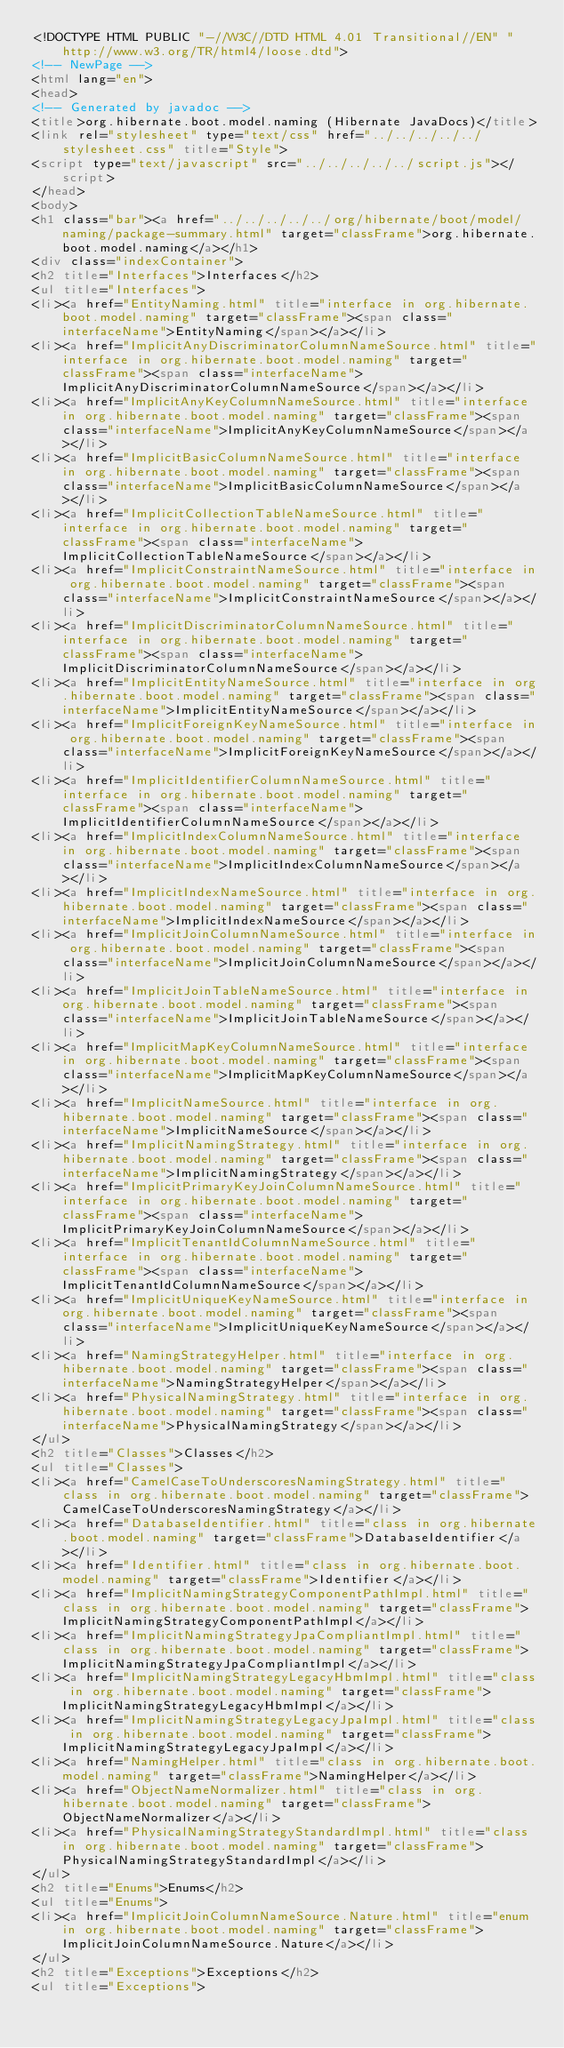Convert code to text. <code><loc_0><loc_0><loc_500><loc_500><_HTML_><!DOCTYPE HTML PUBLIC "-//W3C//DTD HTML 4.01 Transitional//EN" "http://www.w3.org/TR/html4/loose.dtd">
<!-- NewPage -->
<html lang="en">
<head>
<!-- Generated by javadoc -->
<title>org.hibernate.boot.model.naming (Hibernate JavaDocs)</title>
<link rel="stylesheet" type="text/css" href="../../../../../stylesheet.css" title="Style">
<script type="text/javascript" src="../../../../../script.js"></script>
</head>
<body>
<h1 class="bar"><a href="../../../../../org/hibernate/boot/model/naming/package-summary.html" target="classFrame">org.hibernate.boot.model.naming</a></h1>
<div class="indexContainer">
<h2 title="Interfaces">Interfaces</h2>
<ul title="Interfaces">
<li><a href="EntityNaming.html" title="interface in org.hibernate.boot.model.naming" target="classFrame"><span class="interfaceName">EntityNaming</span></a></li>
<li><a href="ImplicitAnyDiscriminatorColumnNameSource.html" title="interface in org.hibernate.boot.model.naming" target="classFrame"><span class="interfaceName">ImplicitAnyDiscriminatorColumnNameSource</span></a></li>
<li><a href="ImplicitAnyKeyColumnNameSource.html" title="interface in org.hibernate.boot.model.naming" target="classFrame"><span class="interfaceName">ImplicitAnyKeyColumnNameSource</span></a></li>
<li><a href="ImplicitBasicColumnNameSource.html" title="interface in org.hibernate.boot.model.naming" target="classFrame"><span class="interfaceName">ImplicitBasicColumnNameSource</span></a></li>
<li><a href="ImplicitCollectionTableNameSource.html" title="interface in org.hibernate.boot.model.naming" target="classFrame"><span class="interfaceName">ImplicitCollectionTableNameSource</span></a></li>
<li><a href="ImplicitConstraintNameSource.html" title="interface in org.hibernate.boot.model.naming" target="classFrame"><span class="interfaceName">ImplicitConstraintNameSource</span></a></li>
<li><a href="ImplicitDiscriminatorColumnNameSource.html" title="interface in org.hibernate.boot.model.naming" target="classFrame"><span class="interfaceName">ImplicitDiscriminatorColumnNameSource</span></a></li>
<li><a href="ImplicitEntityNameSource.html" title="interface in org.hibernate.boot.model.naming" target="classFrame"><span class="interfaceName">ImplicitEntityNameSource</span></a></li>
<li><a href="ImplicitForeignKeyNameSource.html" title="interface in org.hibernate.boot.model.naming" target="classFrame"><span class="interfaceName">ImplicitForeignKeyNameSource</span></a></li>
<li><a href="ImplicitIdentifierColumnNameSource.html" title="interface in org.hibernate.boot.model.naming" target="classFrame"><span class="interfaceName">ImplicitIdentifierColumnNameSource</span></a></li>
<li><a href="ImplicitIndexColumnNameSource.html" title="interface in org.hibernate.boot.model.naming" target="classFrame"><span class="interfaceName">ImplicitIndexColumnNameSource</span></a></li>
<li><a href="ImplicitIndexNameSource.html" title="interface in org.hibernate.boot.model.naming" target="classFrame"><span class="interfaceName">ImplicitIndexNameSource</span></a></li>
<li><a href="ImplicitJoinColumnNameSource.html" title="interface in org.hibernate.boot.model.naming" target="classFrame"><span class="interfaceName">ImplicitJoinColumnNameSource</span></a></li>
<li><a href="ImplicitJoinTableNameSource.html" title="interface in org.hibernate.boot.model.naming" target="classFrame"><span class="interfaceName">ImplicitJoinTableNameSource</span></a></li>
<li><a href="ImplicitMapKeyColumnNameSource.html" title="interface in org.hibernate.boot.model.naming" target="classFrame"><span class="interfaceName">ImplicitMapKeyColumnNameSource</span></a></li>
<li><a href="ImplicitNameSource.html" title="interface in org.hibernate.boot.model.naming" target="classFrame"><span class="interfaceName">ImplicitNameSource</span></a></li>
<li><a href="ImplicitNamingStrategy.html" title="interface in org.hibernate.boot.model.naming" target="classFrame"><span class="interfaceName">ImplicitNamingStrategy</span></a></li>
<li><a href="ImplicitPrimaryKeyJoinColumnNameSource.html" title="interface in org.hibernate.boot.model.naming" target="classFrame"><span class="interfaceName">ImplicitPrimaryKeyJoinColumnNameSource</span></a></li>
<li><a href="ImplicitTenantIdColumnNameSource.html" title="interface in org.hibernate.boot.model.naming" target="classFrame"><span class="interfaceName">ImplicitTenantIdColumnNameSource</span></a></li>
<li><a href="ImplicitUniqueKeyNameSource.html" title="interface in org.hibernate.boot.model.naming" target="classFrame"><span class="interfaceName">ImplicitUniqueKeyNameSource</span></a></li>
<li><a href="NamingStrategyHelper.html" title="interface in org.hibernate.boot.model.naming" target="classFrame"><span class="interfaceName">NamingStrategyHelper</span></a></li>
<li><a href="PhysicalNamingStrategy.html" title="interface in org.hibernate.boot.model.naming" target="classFrame"><span class="interfaceName">PhysicalNamingStrategy</span></a></li>
</ul>
<h2 title="Classes">Classes</h2>
<ul title="Classes">
<li><a href="CamelCaseToUnderscoresNamingStrategy.html" title="class in org.hibernate.boot.model.naming" target="classFrame">CamelCaseToUnderscoresNamingStrategy</a></li>
<li><a href="DatabaseIdentifier.html" title="class in org.hibernate.boot.model.naming" target="classFrame">DatabaseIdentifier</a></li>
<li><a href="Identifier.html" title="class in org.hibernate.boot.model.naming" target="classFrame">Identifier</a></li>
<li><a href="ImplicitNamingStrategyComponentPathImpl.html" title="class in org.hibernate.boot.model.naming" target="classFrame">ImplicitNamingStrategyComponentPathImpl</a></li>
<li><a href="ImplicitNamingStrategyJpaCompliantImpl.html" title="class in org.hibernate.boot.model.naming" target="classFrame">ImplicitNamingStrategyJpaCompliantImpl</a></li>
<li><a href="ImplicitNamingStrategyLegacyHbmImpl.html" title="class in org.hibernate.boot.model.naming" target="classFrame">ImplicitNamingStrategyLegacyHbmImpl</a></li>
<li><a href="ImplicitNamingStrategyLegacyJpaImpl.html" title="class in org.hibernate.boot.model.naming" target="classFrame">ImplicitNamingStrategyLegacyJpaImpl</a></li>
<li><a href="NamingHelper.html" title="class in org.hibernate.boot.model.naming" target="classFrame">NamingHelper</a></li>
<li><a href="ObjectNameNormalizer.html" title="class in org.hibernate.boot.model.naming" target="classFrame">ObjectNameNormalizer</a></li>
<li><a href="PhysicalNamingStrategyStandardImpl.html" title="class in org.hibernate.boot.model.naming" target="classFrame">PhysicalNamingStrategyStandardImpl</a></li>
</ul>
<h2 title="Enums">Enums</h2>
<ul title="Enums">
<li><a href="ImplicitJoinColumnNameSource.Nature.html" title="enum in org.hibernate.boot.model.naming" target="classFrame">ImplicitJoinColumnNameSource.Nature</a></li>
</ul>
<h2 title="Exceptions">Exceptions</h2>
<ul title="Exceptions"></code> 